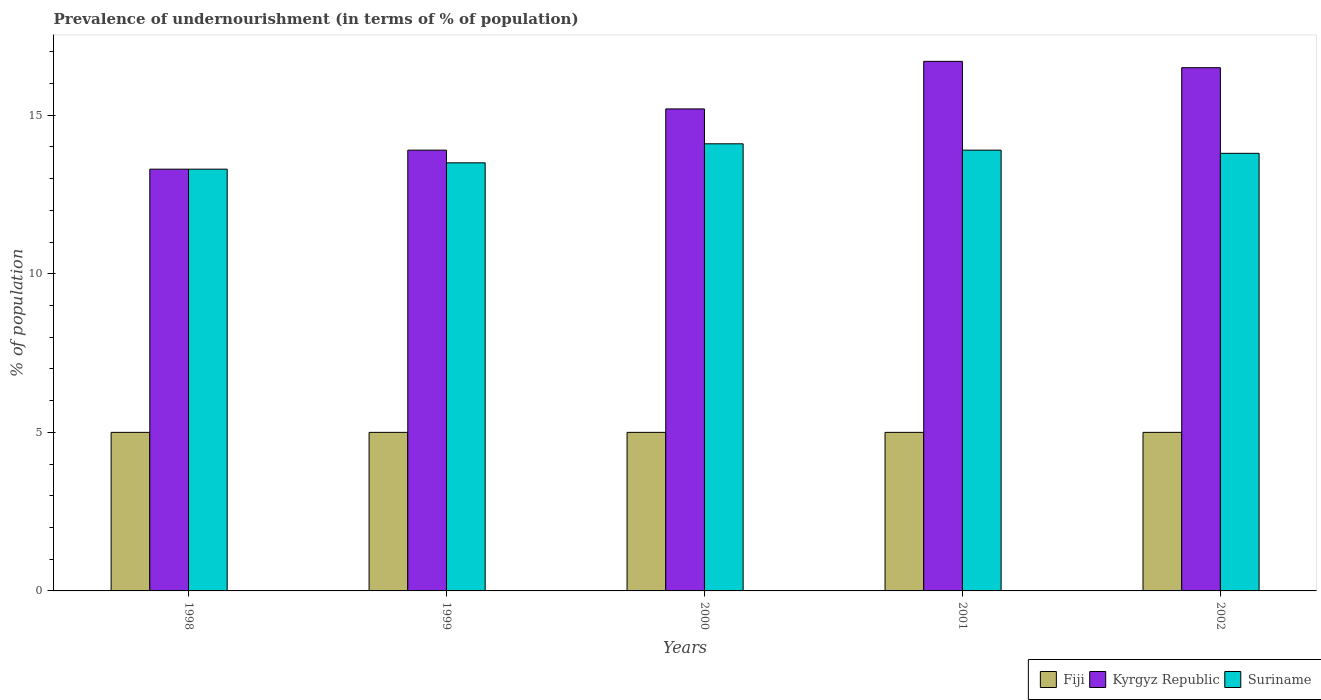How many different coloured bars are there?
Provide a short and direct response. 3. Are the number of bars on each tick of the X-axis equal?
Your answer should be very brief. Yes. How many bars are there on the 5th tick from the left?
Your answer should be compact. 3. How many bars are there on the 3rd tick from the right?
Offer a very short reply. 3. What is the label of the 1st group of bars from the left?
Make the answer very short. 1998. In how many cases, is the number of bars for a given year not equal to the number of legend labels?
Offer a very short reply. 0. In which year was the percentage of undernourished population in Suriname maximum?
Your response must be concise. 2000. In which year was the percentage of undernourished population in Fiji minimum?
Offer a very short reply. 1998. What is the difference between the percentage of undernourished population in Kyrgyz Republic in 2000 and that in 2002?
Provide a succinct answer. -1.3. What is the difference between the percentage of undernourished population in Fiji in 1998 and the percentage of undernourished population in Suriname in 2001?
Keep it short and to the point. -8.9. What is the average percentage of undernourished population in Kyrgyz Republic per year?
Your answer should be compact. 15.12. In the year 1999, what is the difference between the percentage of undernourished population in Fiji and percentage of undernourished population in Suriname?
Your answer should be very brief. -8.5. In how many years, is the percentage of undernourished population in Fiji greater than 13 %?
Your answer should be compact. 0. What is the ratio of the percentage of undernourished population in Kyrgyz Republic in 1999 to that in 2000?
Your answer should be compact. 0.91. Is the percentage of undernourished population in Kyrgyz Republic in 1998 less than that in 2000?
Offer a terse response. Yes. What is the difference between the highest and the second highest percentage of undernourished population in Suriname?
Your answer should be very brief. 0.2. What is the difference between the highest and the lowest percentage of undernourished population in Kyrgyz Republic?
Keep it short and to the point. 3.4. What does the 1st bar from the left in 1998 represents?
Provide a short and direct response. Fiji. What does the 3rd bar from the right in 1998 represents?
Ensure brevity in your answer.  Fiji. Is it the case that in every year, the sum of the percentage of undernourished population in Fiji and percentage of undernourished population in Suriname is greater than the percentage of undernourished population in Kyrgyz Republic?
Provide a succinct answer. Yes. How many bars are there?
Offer a very short reply. 15. How many years are there in the graph?
Ensure brevity in your answer.  5. Are the values on the major ticks of Y-axis written in scientific E-notation?
Give a very brief answer. No. Does the graph contain any zero values?
Provide a succinct answer. No. Where does the legend appear in the graph?
Your response must be concise. Bottom right. How are the legend labels stacked?
Provide a short and direct response. Horizontal. What is the title of the graph?
Provide a short and direct response. Prevalence of undernourishment (in terms of % of population). What is the label or title of the Y-axis?
Make the answer very short. % of population. What is the % of population in Fiji in 2000?
Provide a short and direct response. 5. What is the % of population of Fiji in 2001?
Keep it short and to the point. 5. What is the % of population of Kyrgyz Republic in 2001?
Ensure brevity in your answer.  16.7. What is the % of population of Suriname in 2001?
Ensure brevity in your answer.  13.9. What is the % of population in Kyrgyz Republic in 2002?
Give a very brief answer. 16.5. Across all years, what is the maximum % of population in Fiji?
Ensure brevity in your answer.  5. Across all years, what is the maximum % of population in Suriname?
Give a very brief answer. 14.1. Across all years, what is the minimum % of population in Kyrgyz Republic?
Your response must be concise. 13.3. Across all years, what is the minimum % of population in Suriname?
Give a very brief answer. 13.3. What is the total % of population in Kyrgyz Republic in the graph?
Your answer should be compact. 75.6. What is the total % of population in Suriname in the graph?
Your answer should be very brief. 68.6. What is the difference between the % of population of Kyrgyz Republic in 1998 and that in 2000?
Ensure brevity in your answer.  -1.9. What is the difference between the % of population in Suriname in 1998 and that in 2002?
Your response must be concise. -0.5. What is the difference between the % of population of Kyrgyz Republic in 1999 and that in 2001?
Offer a terse response. -2.8. What is the difference between the % of population in Suriname in 1999 and that in 2001?
Keep it short and to the point. -0.4. What is the difference between the % of population of Suriname in 1999 and that in 2002?
Keep it short and to the point. -0.3. What is the difference between the % of population of Kyrgyz Republic in 2000 and that in 2001?
Keep it short and to the point. -1.5. What is the difference between the % of population of Fiji in 2000 and that in 2002?
Your response must be concise. 0. What is the difference between the % of population of Kyrgyz Republic in 2001 and that in 2002?
Offer a terse response. 0.2. What is the difference between the % of population of Suriname in 2001 and that in 2002?
Offer a very short reply. 0.1. What is the difference between the % of population of Kyrgyz Republic in 1998 and the % of population of Suriname in 1999?
Your answer should be very brief. -0.2. What is the difference between the % of population of Fiji in 1998 and the % of population of Kyrgyz Republic in 2000?
Your response must be concise. -10.2. What is the difference between the % of population of Kyrgyz Republic in 1998 and the % of population of Suriname in 2000?
Provide a succinct answer. -0.8. What is the difference between the % of population in Fiji in 1998 and the % of population in Kyrgyz Republic in 2001?
Your answer should be compact. -11.7. What is the difference between the % of population in Kyrgyz Republic in 1998 and the % of population in Suriname in 2001?
Offer a very short reply. -0.6. What is the difference between the % of population in Kyrgyz Republic in 1998 and the % of population in Suriname in 2002?
Your answer should be compact. -0.5. What is the difference between the % of population of Fiji in 1999 and the % of population of Kyrgyz Republic in 2000?
Ensure brevity in your answer.  -10.2. What is the difference between the % of population in Kyrgyz Republic in 1999 and the % of population in Suriname in 2000?
Provide a short and direct response. -0.2. What is the difference between the % of population of Fiji in 1999 and the % of population of Suriname in 2001?
Keep it short and to the point. -8.9. What is the difference between the % of population of Kyrgyz Republic in 1999 and the % of population of Suriname in 2001?
Provide a short and direct response. 0. What is the difference between the % of population in Kyrgyz Republic in 1999 and the % of population in Suriname in 2002?
Offer a very short reply. 0.1. What is the difference between the % of population in Fiji in 2000 and the % of population in Kyrgyz Republic in 2001?
Ensure brevity in your answer.  -11.7. What is the difference between the % of population of Kyrgyz Republic in 2000 and the % of population of Suriname in 2001?
Ensure brevity in your answer.  1.3. What is the difference between the % of population of Fiji in 2000 and the % of population of Kyrgyz Republic in 2002?
Offer a terse response. -11.5. What is the average % of population of Fiji per year?
Your answer should be very brief. 5. What is the average % of population of Kyrgyz Republic per year?
Ensure brevity in your answer.  15.12. What is the average % of population of Suriname per year?
Provide a short and direct response. 13.72. In the year 1998, what is the difference between the % of population in Fiji and % of population in Suriname?
Make the answer very short. -8.3. In the year 1999, what is the difference between the % of population in Fiji and % of population in Kyrgyz Republic?
Provide a short and direct response. -8.9. In the year 1999, what is the difference between the % of population in Kyrgyz Republic and % of population in Suriname?
Keep it short and to the point. 0.4. In the year 2000, what is the difference between the % of population in Fiji and % of population in Kyrgyz Republic?
Give a very brief answer. -10.2. In the year 2001, what is the difference between the % of population in Fiji and % of population in Kyrgyz Republic?
Your answer should be compact. -11.7. In the year 2001, what is the difference between the % of population in Fiji and % of population in Suriname?
Your answer should be very brief. -8.9. In the year 2002, what is the difference between the % of population of Kyrgyz Republic and % of population of Suriname?
Ensure brevity in your answer.  2.7. What is the ratio of the % of population of Fiji in 1998 to that in 1999?
Your answer should be compact. 1. What is the ratio of the % of population in Kyrgyz Republic in 1998 to that in 1999?
Offer a very short reply. 0.96. What is the ratio of the % of population in Suriname in 1998 to that in 1999?
Offer a very short reply. 0.99. What is the ratio of the % of population in Fiji in 1998 to that in 2000?
Give a very brief answer. 1. What is the ratio of the % of population in Kyrgyz Republic in 1998 to that in 2000?
Provide a succinct answer. 0.88. What is the ratio of the % of population of Suriname in 1998 to that in 2000?
Provide a succinct answer. 0.94. What is the ratio of the % of population of Kyrgyz Republic in 1998 to that in 2001?
Your response must be concise. 0.8. What is the ratio of the % of population of Suriname in 1998 to that in 2001?
Your answer should be compact. 0.96. What is the ratio of the % of population in Fiji in 1998 to that in 2002?
Give a very brief answer. 1. What is the ratio of the % of population in Kyrgyz Republic in 1998 to that in 2002?
Provide a short and direct response. 0.81. What is the ratio of the % of population in Suriname in 1998 to that in 2002?
Give a very brief answer. 0.96. What is the ratio of the % of population in Fiji in 1999 to that in 2000?
Your answer should be very brief. 1. What is the ratio of the % of population of Kyrgyz Republic in 1999 to that in 2000?
Provide a succinct answer. 0.91. What is the ratio of the % of population in Suriname in 1999 to that in 2000?
Offer a very short reply. 0.96. What is the ratio of the % of population of Kyrgyz Republic in 1999 to that in 2001?
Keep it short and to the point. 0.83. What is the ratio of the % of population of Suriname in 1999 to that in 2001?
Offer a terse response. 0.97. What is the ratio of the % of population in Fiji in 1999 to that in 2002?
Offer a terse response. 1. What is the ratio of the % of population of Kyrgyz Republic in 1999 to that in 2002?
Your answer should be very brief. 0.84. What is the ratio of the % of population of Suriname in 1999 to that in 2002?
Your answer should be very brief. 0.98. What is the ratio of the % of population of Fiji in 2000 to that in 2001?
Ensure brevity in your answer.  1. What is the ratio of the % of population of Kyrgyz Republic in 2000 to that in 2001?
Provide a succinct answer. 0.91. What is the ratio of the % of population of Suriname in 2000 to that in 2001?
Offer a terse response. 1.01. What is the ratio of the % of population of Kyrgyz Republic in 2000 to that in 2002?
Ensure brevity in your answer.  0.92. What is the ratio of the % of population in Suriname in 2000 to that in 2002?
Ensure brevity in your answer.  1.02. What is the ratio of the % of population of Kyrgyz Republic in 2001 to that in 2002?
Your response must be concise. 1.01. What is the difference between the highest and the second highest % of population of Fiji?
Offer a very short reply. 0. What is the difference between the highest and the second highest % of population of Kyrgyz Republic?
Ensure brevity in your answer.  0.2. What is the difference between the highest and the second highest % of population of Suriname?
Ensure brevity in your answer.  0.2. What is the difference between the highest and the lowest % of population in Fiji?
Provide a succinct answer. 0. What is the difference between the highest and the lowest % of population of Suriname?
Your answer should be compact. 0.8. 